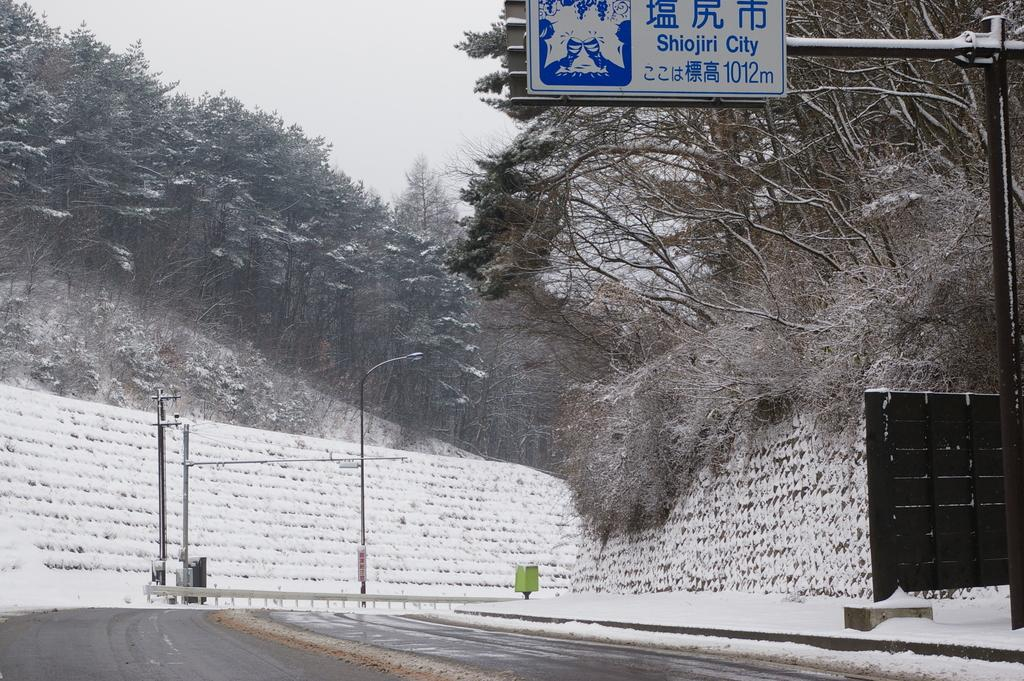What can be seen in the center of the image? There are poles in the center of the image. What is visible in the background of the image? There are trees in the background of the image. What is located in the front of the image? There is a board with text written on it in the front of the image. How many cacti are present in the image? There are no cacti present in the image; only poles, trees, and a board with text are visible. What type of fly can be seen buzzing around the board in the image? There are no flies present in the image. 